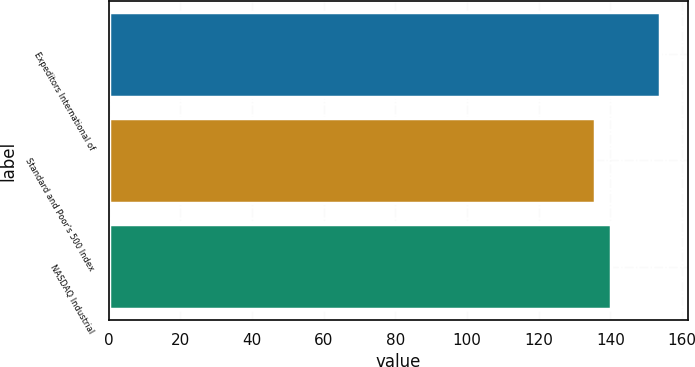Convert chart. <chart><loc_0><loc_0><loc_500><loc_500><bar_chart><fcel>Expeditors International of<fcel>Standard and Poor's 500 Index<fcel>NASDAQ Industrial<nl><fcel>153.88<fcel>135.63<fcel>140.25<nl></chart> 